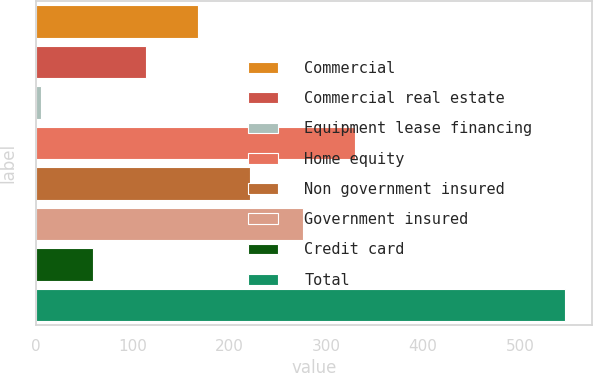Convert chart. <chart><loc_0><loc_0><loc_500><loc_500><bar_chart><fcel>Commercial<fcel>Commercial real estate<fcel>Equipment lease financing<fcel>Home equity<fcel>Non government insured<fcel>Government insured<fcel>Credit card<fcel>Total<nl><fcel>167.6<fcel>113.4<fcel>5<fcel>330.2<fcel>221.8<fcel>276<fcel>59.2<fcel>547<nl></chart> 